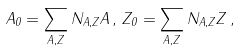<formula> <loc_0><loc_0><loc_500><loc_500>A _ { 0 } = \sum _ { A , Z } N _ { A , Z } A \, , \, Z _ { 0 } = \sum _ { A , Z } N _ { A , Z } Z \, ,</formula> 